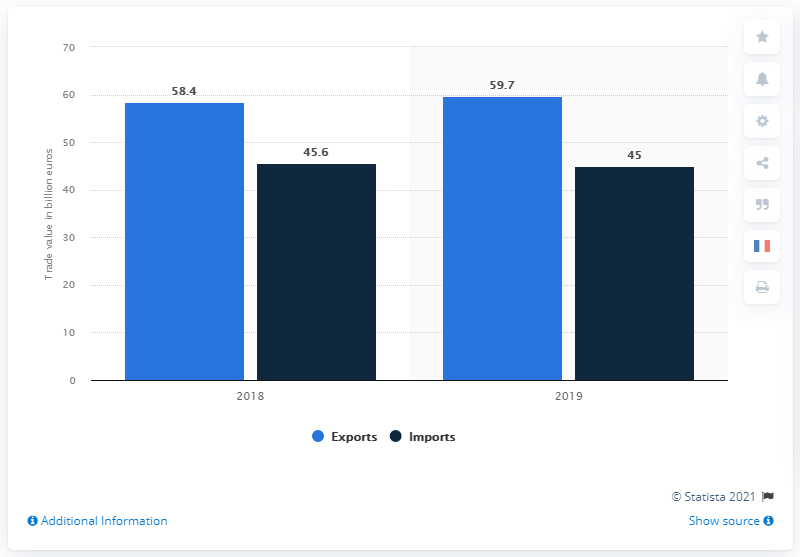What was the value of French exports of chemicals, cosmetics and perfumes in 2019? In 2019, France exported chemicals, cosmetics, and perfumes valued at approximately 59.7 billion US dollars, according to the graph. This represents a slight increase from the previous year, 2018, where exports stood at 58.4 billion US dollars. 